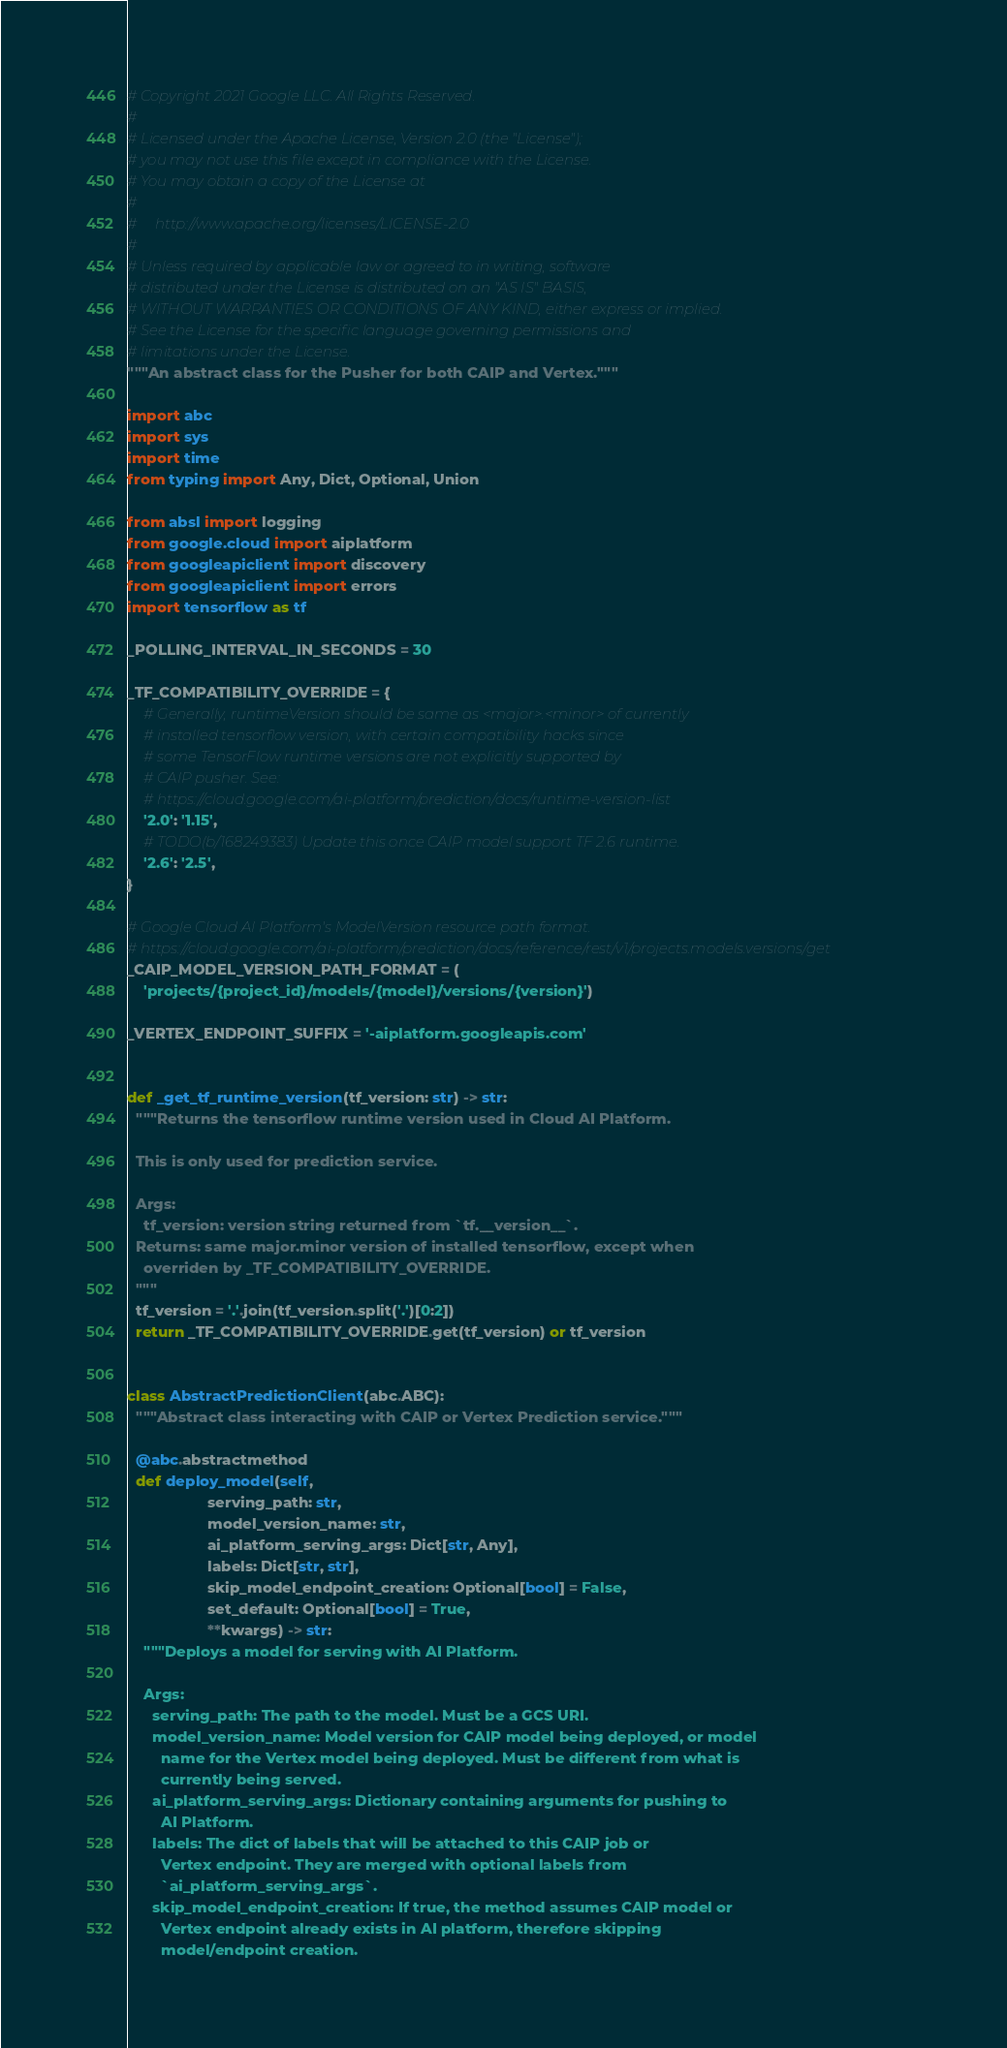<code> <loc_0><loc_0><loc_500><loc_500><_Python_># Copyright 2021 Google LLC. All Rights Reserved.
#
# Licensed under the Apache License, Version 2.0 (the "License");
# you may not use this file except in compliance with the License.
# You may obtain a copy of the License at
#
#     http://www.apache.org/licenses/LICENSE-2.0
#
# Unless required by applicable law or agreed to in writing, software
# distributed under the License is distributed on an "AS IS" BASIS,
# WITHOUT WARRANTIES OR CONDITIONS OF ANY KIND, either express or implied.
# See the License for the specific language governing permissions and
# limitations under the License.
"""An abstract class for the Pusher for both CAIP and Vertex."""

import abc
import sys
import time
from typing import Any, Dict, Optional, Union

from absl import logging
from google.cloud import aiplatform
from googleapiclient import discovery
from googleapiclient import errors
import tensorflow as tf

_POLLING_INTERVAL_IN_SECONDS = 30

_TF_COMPATIBILITY_OVERRIDE = {
    # Generally, runtimeVersion should be same as <major>.<minor> of currently
    # installed tensorflow version, with certain compatibility hacks since
    # some TensorFlow runtime versions are not explicitly supported by
    # CAIP pusher. See:
    # https://cloud.google.com/ai-platform/prediction/docs/runtime-version-list
    '2.0': '1.15',
    # TODO(b/168249383) Update this once CAIP model support TF 2.6 runtime.
    '2.6': '2.5',
}

# Google Cloud AI Platform's ModelVersion resource path format.
# https://cloud.google.com/ai-platform/prediction/docs/reference/rest/v1/projects.models.versions/get
_CAIP_MODEL_VERSION_PATH_FORMAT = (
    'projects/{project_id}/models/{model}/versions/{version}')

_VERTEX_ENDPOINT_SUFFIX = '-aiplatform.googleapis.com'


def _get_tf_runtime_version(tf_version: str) -> str:
  """Returns the tensorflow runtime version used in Cloud AI Platform.

  This is only used for prediction service.

  Args:
    tf_version: version string returned from `tf.__version__`.
  Returns: same major.minor version of installed tensorflow, except when
    overriden by _TF_COMPATIBILITY_OVERRIDE.
  """
  tf_version = '.'.join(tf_version.split('.')[0:2])
  return _TF_COMPATIBILITY_OVERRIDE.get(tf_version) or tf_version


class AbstractPredictionClient(abc.ABC):
  """Abstract class interacting with CAIP or Vertex Prediction service."""

  @abc.abstractmethod
  def deploy_model(self,
                   serving_path: str,
                   model_version_name: str,
                   ai_platform_serving_args: Dict[str, Any],
                   labels: Dict[str, str],
                   skip_model_endpoint_creation: Optional[bool] = False,
                   set_default: Optional[bool] = True,
                   **kwargs) -> str:
    """Deploys a model for serving with AI Platform.

    Args:
      serving_path: The path to the model. Must be a GCS URI.
      model_version_name: Model version for CAIP model being deployed, or model
        name for the Vertex model being deployed. Must be different from what is
        currently being served.
      ai_platform_serving_args: Dictionary containing arguments for pushing to
        AI Platform.
      labels: The dict of labels that will be attached to this CAIP job or
        Vertex endpoint. They are merged with optional labels from
        `ai_platform_serving_args`.
      skip_model_endpoint_creation: If true, the method assumes CAIP model or
        Vertex endpoint already exists in AI platform, therefore skipping
        model/endpoint creation.</code> 